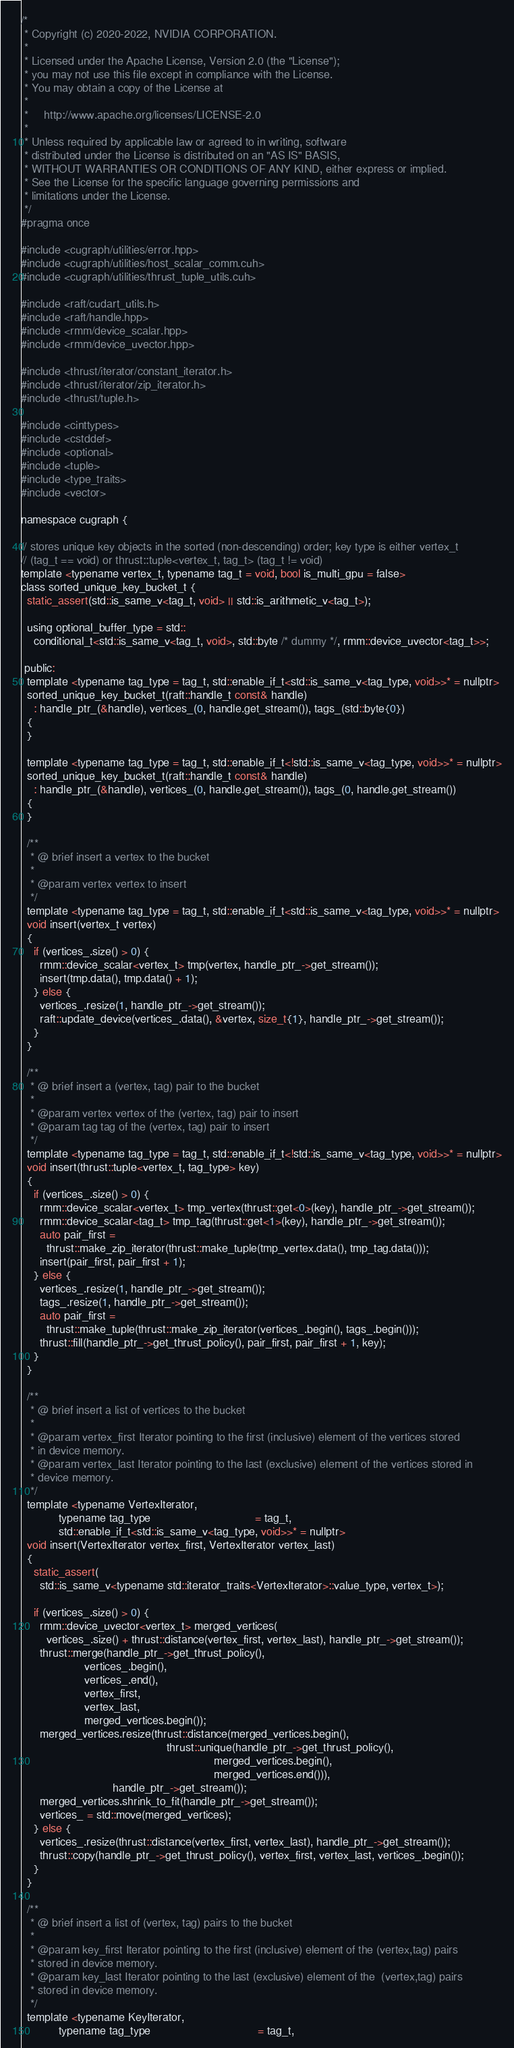<code> <loc_0><loc_0><loc_500><loc_500><_Cuda_>/*
 * Copyright (c) 2020-2022, NVIDIA CORPORATION.
 *
 * Licensed under the Apache License, Version 2.0 (the "License");
 * you may not use this file except in compliance with the License.
 * You may obtain a copy of the License at
 *
 *     http://www.apache.org/licenses/LICENSE-2.0
 *
 * Unless required by applicable law or agreed to in writing, software
 * distributed under the License is distributed on an "AS IS" BASIS,
 * WITHOUT WARRANTIES OR CONDITIONS OF ANY KIND, either express or implied.
 * See the License for the specific language governing permissions and
 * limitations under the License.
 */
#pragma once

#include <cugraph/utilities/error.hpp>
#include <cugraph/utilities/host_scalar_comm.cuh>
#include <cugraph/utilities/thrust_tuple_utils.cuh>

#include <raft/cudart_utils.h>
#include <raft/handle.hpp>
#include <rmm/device_scalar.hpp>
#include <rmm/device_uvector.hpp>

#include <thrust/iterator/constant_iterator.h>
#include <thrust/iterator/zip_iterator.h>
#include <thrust/tuple.h>

#include <cinttypes>
#include <cstddef>
#include <optional>
#include <tuple>
#include <type_traits>
#include <vector>

namespace cugraph {

// stores unique key objects in the sorted (non-descending) order; key type is either vertex_t
// (tag_t == void) or thrust::tuple<vertex_t, tag_t> (tag_t != void)
template <typename vertex_t, typename tag_t = void, bool is_multi_gpu = false>
class sorted_unique_key_bucket_t {
  static_assert(std::is_same_v<tag_t, void> || std::is_arithmetic_v<tag_t>);

  using optional_buffer_type = std::
    conditional_t<std::is_same_v<tag_t, void>, std::byte /* dummy */, rmm::device_uvector<tag_t>>;

 public:
  template <typename tag_type = tag_t, std::enable_if_t<std::is_same_v<tag_type, void>>* = nullptr>
  sorted_unique_key_bucket_t(raft::handle_t const& handle)
    : handle_ptr_(&handle), vertices_(0, handle.get_stream()), tags_(std::byte{0})
  {
  }

  template <typename tag_type = tag_t, std::enable_if_t<!std::is_same_v<tag_type, void>>* = nullptr>
  sorted_unique_key_bucket_t(raft::handle_t const& handle)
    : handle_ptr_(&handle), vertices_(0, handle.get_stream()), tags_(0, handle.get_stream())
  {
  }

  /**
   * @ brief insert a vertex to the bucket
   *
   * @param vertex vertex to insert
   */
  template <typename tag_type = tag_t, std::enable_if_t<std::is_same_v<tag_type, void>>* = nullptr>
  void insert(vertex_t vertex)
  {
    if (vertices_.size() > 0) {
      rmm::device_scalar<vertex_t> tmp(vertex, handle_ptr_->get_stream());
      insert(tmp.data(), tmp.data() + 1);
    } else {
      vertices_.resize(1, handle_ptr_->get_stream());
      raft::update_device(vertices_.data(), &vertex, size_t{1}, handle_ptr_->get_stream());
    }
  }

  /**
   * @ brief insert a (vertex, tag) pair to the bucket
   *
   * @param vertex vertex of the (vertex, tag) pair to insert
   * @param tag tag of the (vertex, tag) pair to insert
   */
  template <typename tag_type = tag_t, std::enable_if_t<!std::is_same_v<tag_type, void>>* = nullptr>
  void insert(thrust::tuple<vertex_t, tag_type> key)
  {
    if (vertices_.size() > 0) {
      rmm::device_scalar<vertex_t> tmp_vertex(thrust::get<0>(key), handle_ptr_->get_stream());
      rmm::device_scalar<tag_t> tmp_tag(thrust::get<1>(key), handle_ptr_->get_stream());
      auto pair_first =
        thrust::make_zip_iterator(thrust::make_tuple(tmp_vertex.data(), tmp_tag.data()));
      insert(pair_first, pair_first + 1);
    } else {
      vertices_.resize(1, handle_ptr_->get_stream());
      tags_.resize(1, handle_ptr_->get_stream());
      auto pair_first =
        thrust::make_tuple(thrust::make_zip_iterator(vertices_.begin(), tags_.begin()));
      thrust::fill(handle_ptr_->get_thrust_policy(), pair_first, pair_first + 1, key);
    }
  }

  /**
   * @ brief insert a list of vertices to the bucket
   *
   * @param vertex_first Iterator pointing to the first (inclusive) element of the vertices stored
   * in device memory.
   * @param vertex_last Iterator pointing to the last (exclusive) element of the vertices stored in
   * device memory.
   */
  template <typename VertexIterator,
            typename tag_type                                 = tag_t,
            std::enable_if_t<std::is_same_v<tag_type, void>>* = nullptr>
  void insert(VertexIterator vertex_first, VertexIterator vertex_last)
  {
    static_assert(
      std::is_same_v<typename std::iterator_traits<VertexIterator>::value_type, vertex_t>);

    if (vertices_.size() > 0) {
      rmm::device_uvector<vertex_t> merged_vertices(
        vertices_.size() + thrust::distance(vertex_first, vertex_last), handle_ptr_->get_stream());
      thrust::merge(handle_ptr_->get_thrust_policy(),
                    vertices_.begin(),
                    vertices_.end(),
                    vertex_first,
                    vertex_last,
                    merged_vertices.begin());
      merged_vertices.resize(thrust::distance(merged_vertices.begin(),
                                              thrust::unique(handle_ptr_->get_thrust_policy(),
                                                             merged_vertices.begin(),
                                                             merged_vertices.end())),
                             handle_ptr_->get_stream());
      merged_vertices.shrink_to_fit(handle_ptr_->get_stream());
      vertices_ = std::move(merged_vertices);
    } else {
      vertices_.resize(thrust::distance(vertex_first, vertex_last), handle_ptr_->get_stream());
      thrust::copy(handle_ptr_->get_thrust_policy(), vertex_first, vertex_last, vertices_.begin());
    }
  }

  /**
   * @ brief insert a list of (vertex, tag) pairs to the bucket
   *
   * @param key_first Iterator pointing to the first (inclusive) element of the (vertex,tag) pairs
   * stored in device memory.
   * @param key_last Iterator pointing to the last (exclusive) element of the  (vertex,tag) pairs
   * stored in device memory.
   */
  template <typename KeyIterator,
            typename tag_type                                  = tag_t,</code> 